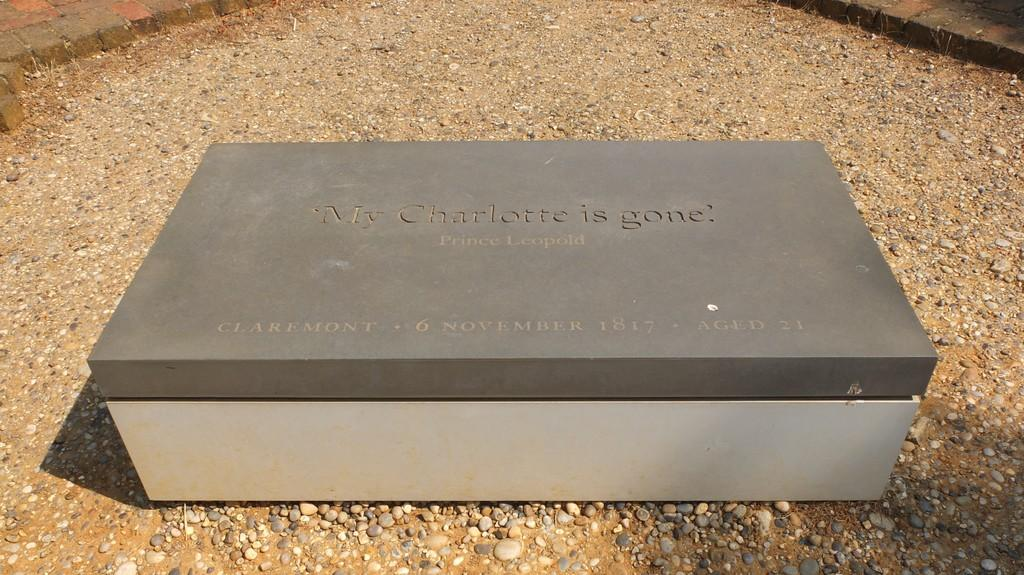<image>
Share a concise interpretation of the image provided. A stone tablet saying My Charlotte is gone is over a gravel area. 